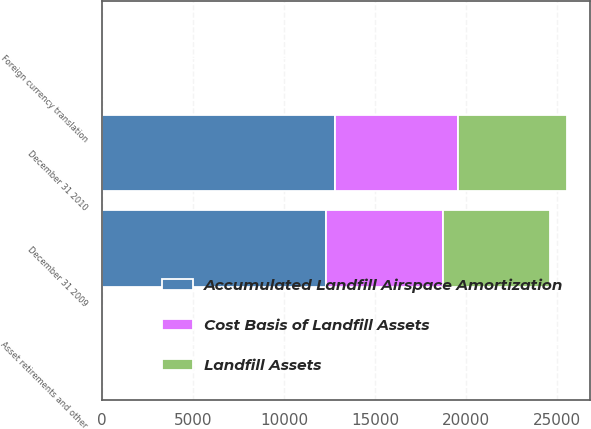Convert chart to OTSL. <chart><loc_0><loc_0><loc_500><loc_500><stacked_bar_chart><ecel><fcel>December 31 2009<fcel>Foreign currency translation<fcel>Asset retirements and other<fcel>December 31 2010<nl><fcel>Accumulated Landfill Airspace Amortization<fcel>12301<fcel>70<fcel>69<fcel>12777<nl><fcel>Cost Basis of Landfill Assets<fcel>6448<fcel>19<fcel>47<fcel>6792<nl><fcel>Landfill Assets<fcel>5853<fcel>51<fcel>22<fcel>5985<nl></chart> 